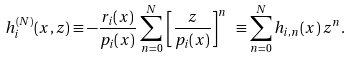<formula> <loc_0><loc_0><loc_500><loc_500>h _ { i } ^ { ( N ) } ( x , z ) \equiv - \frac { r _ { i } ( x ) } { p _ { i } ( x ) } \, \sum _ { n = 0 } ^ { N } \, { \left [ \frac { z } { p _ { i } ( x ) } \right ] } ^ { n } \ \equiv \sum _ { n = 0 } ^ { N } h _ { i , n } ( x ) \, z ^ { n } .</formula> 